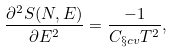Convert formula to latex. <formula><loc_0><loc_0><loc_500><loc_500>\frac { \partial ^ { 2 } S ( N , E ) } { \partial E ^ { 2 } } = \frac { - 1 } { C _ { \S c v } T ^ { 2 } } ,</formula> 